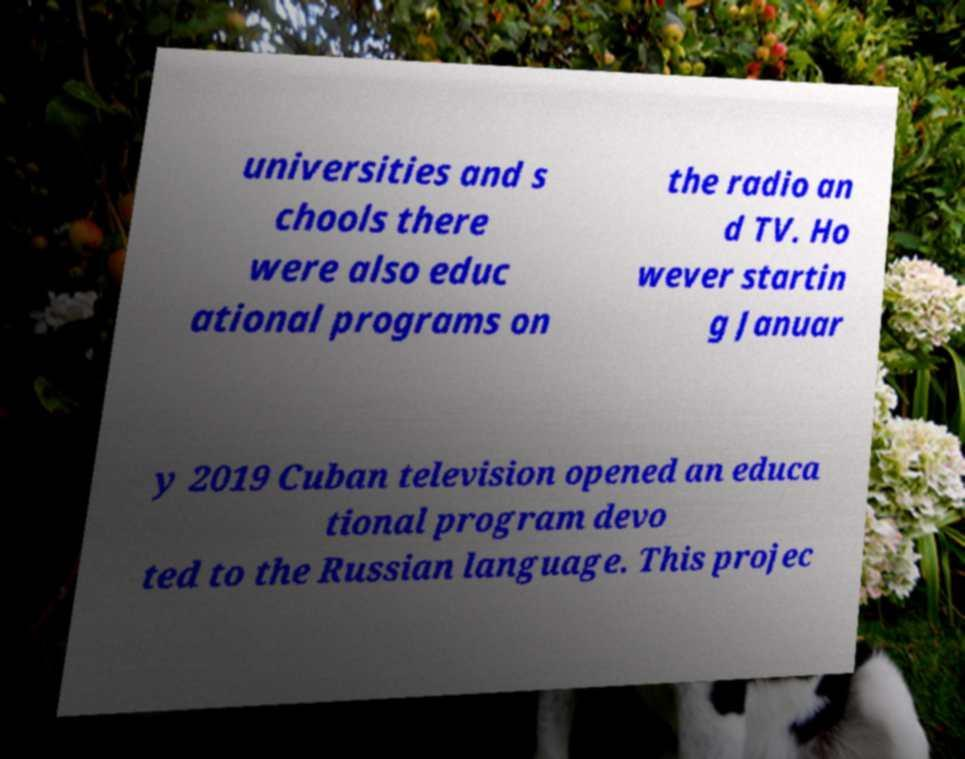Please identify and transcribe the text found in this image. universities and s chools there were also educ ational programs on the radio an d TV. Ho wever startin g Januar y 2019 Cuban television opened an educa tional program devo ted to the Russian language. This projec 